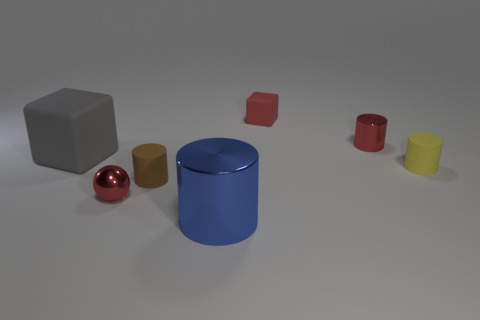What material is the cube that is in front of the rubber object that is behind the metal cylinder that is behind the big blue metal thing?
Ensure brevity in your answer.  Rubber. Is there any other thing that is the same shape as the tiny brown object?
Ensure brevity in your answer.  Yes. There is another small matte thing that is the same shape as the gray thing; what is its color?
Give a very brief answer. Red. There is a shiny cylinder that is in front of the red shiny ball; does it have the same color as the tiny metal thing on the right side of the shiny ball?
Your answer should be compact. No. Are there more small brown matte cylinders behind the gray matte object than small rubber things?
Make the answer very short. No. What number of other objects are the same size as the yellow rubber cylinder?
Your answer should be very brief. 4. How many small things are in front of the brown thing and on the right side of the large blue shiny thing?
Your answer should be very brief. 0. Is the block right of the large cylinder made of the same material as the gray object?
Keep it short and to the point. Yes. The small rubber object behind the red metallic object that is on the right side of the metal object that is in front of the metal ball is what shape?
Provide a short and direct response. Cube. Is the number of matte cylinders behind the small yellow cylinder the same as the number of brown rubber cylinders on the right side of the tiny matte cube?
Keep it short and to the point. Yes. 